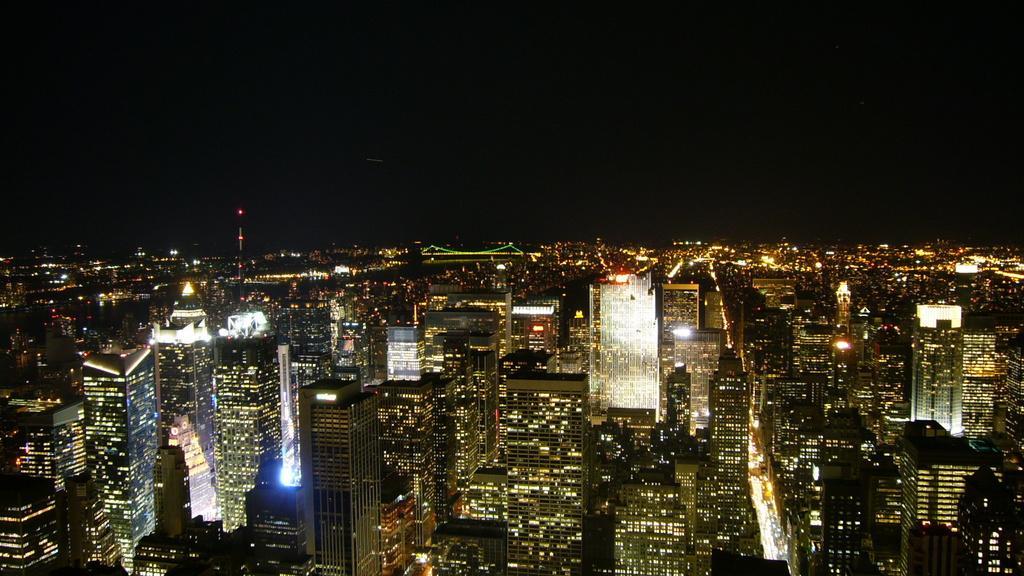Can you describe this image briefly? In this image at the bottom, there are many buildings, lightnings, vehicles, bridge, towers. At the top there is sky. 